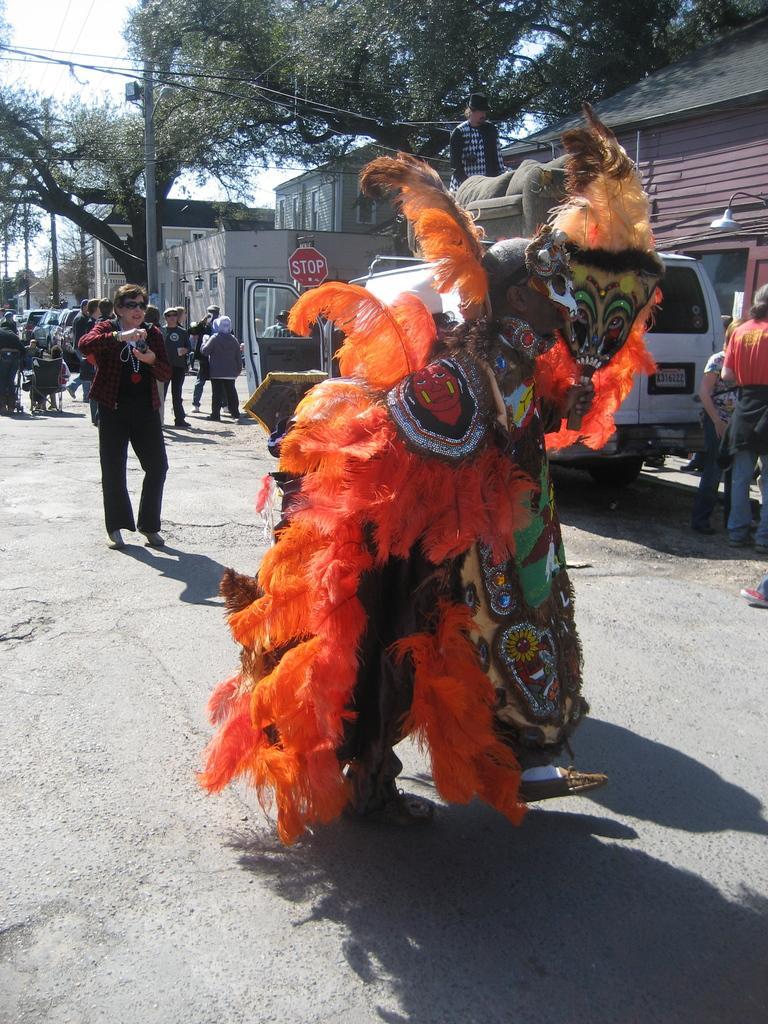Please provide a concise description of this image. In this image, I can see a person standing with fancy dress. In the background, I can see groups of people standing. There are buildings, trees, a current pole and vehicles on the road. 